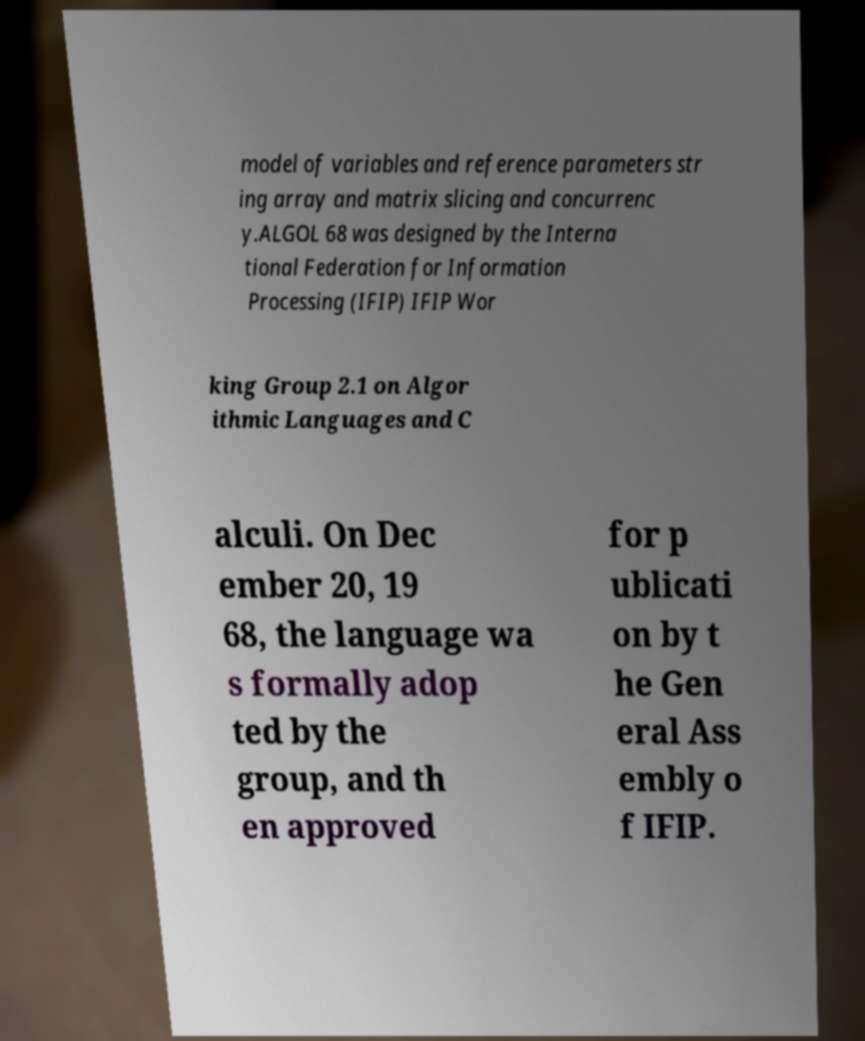Could you extract and type out the text from this image? model of variables and reference parameters str ing array and matrix slicing and concurrenc y.ALGOL 68 was designed by the Interna tional Federation for Information Processing (IFIP) IFIP Wor king Group 2.1 on Algor ithmic Languages and C alculi. On Dec ember 20, 19 68, the language wa s formally adop ted by the group, and th en approved for p ublicati on by t he Gen eral Ass embly o f IFIP. 